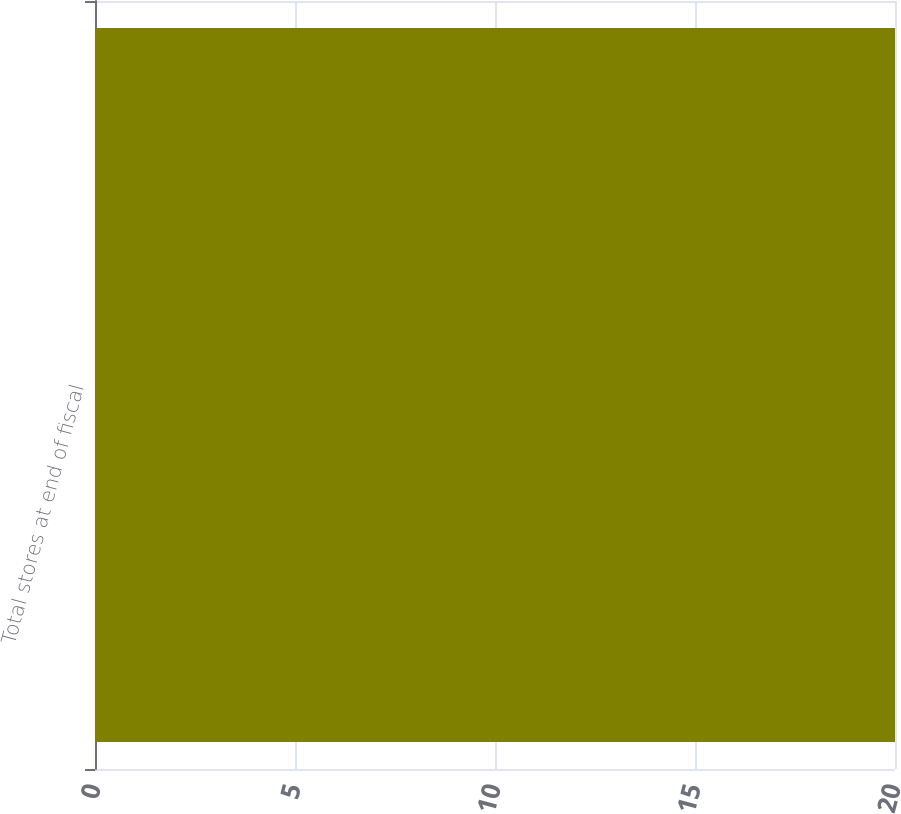Convert chart. <chart><loc_0><loc_0><loc_500><loc_500><bar_chart><fcel>Total stores at end of fiscal<nl><fcel>20<nl></chart> 